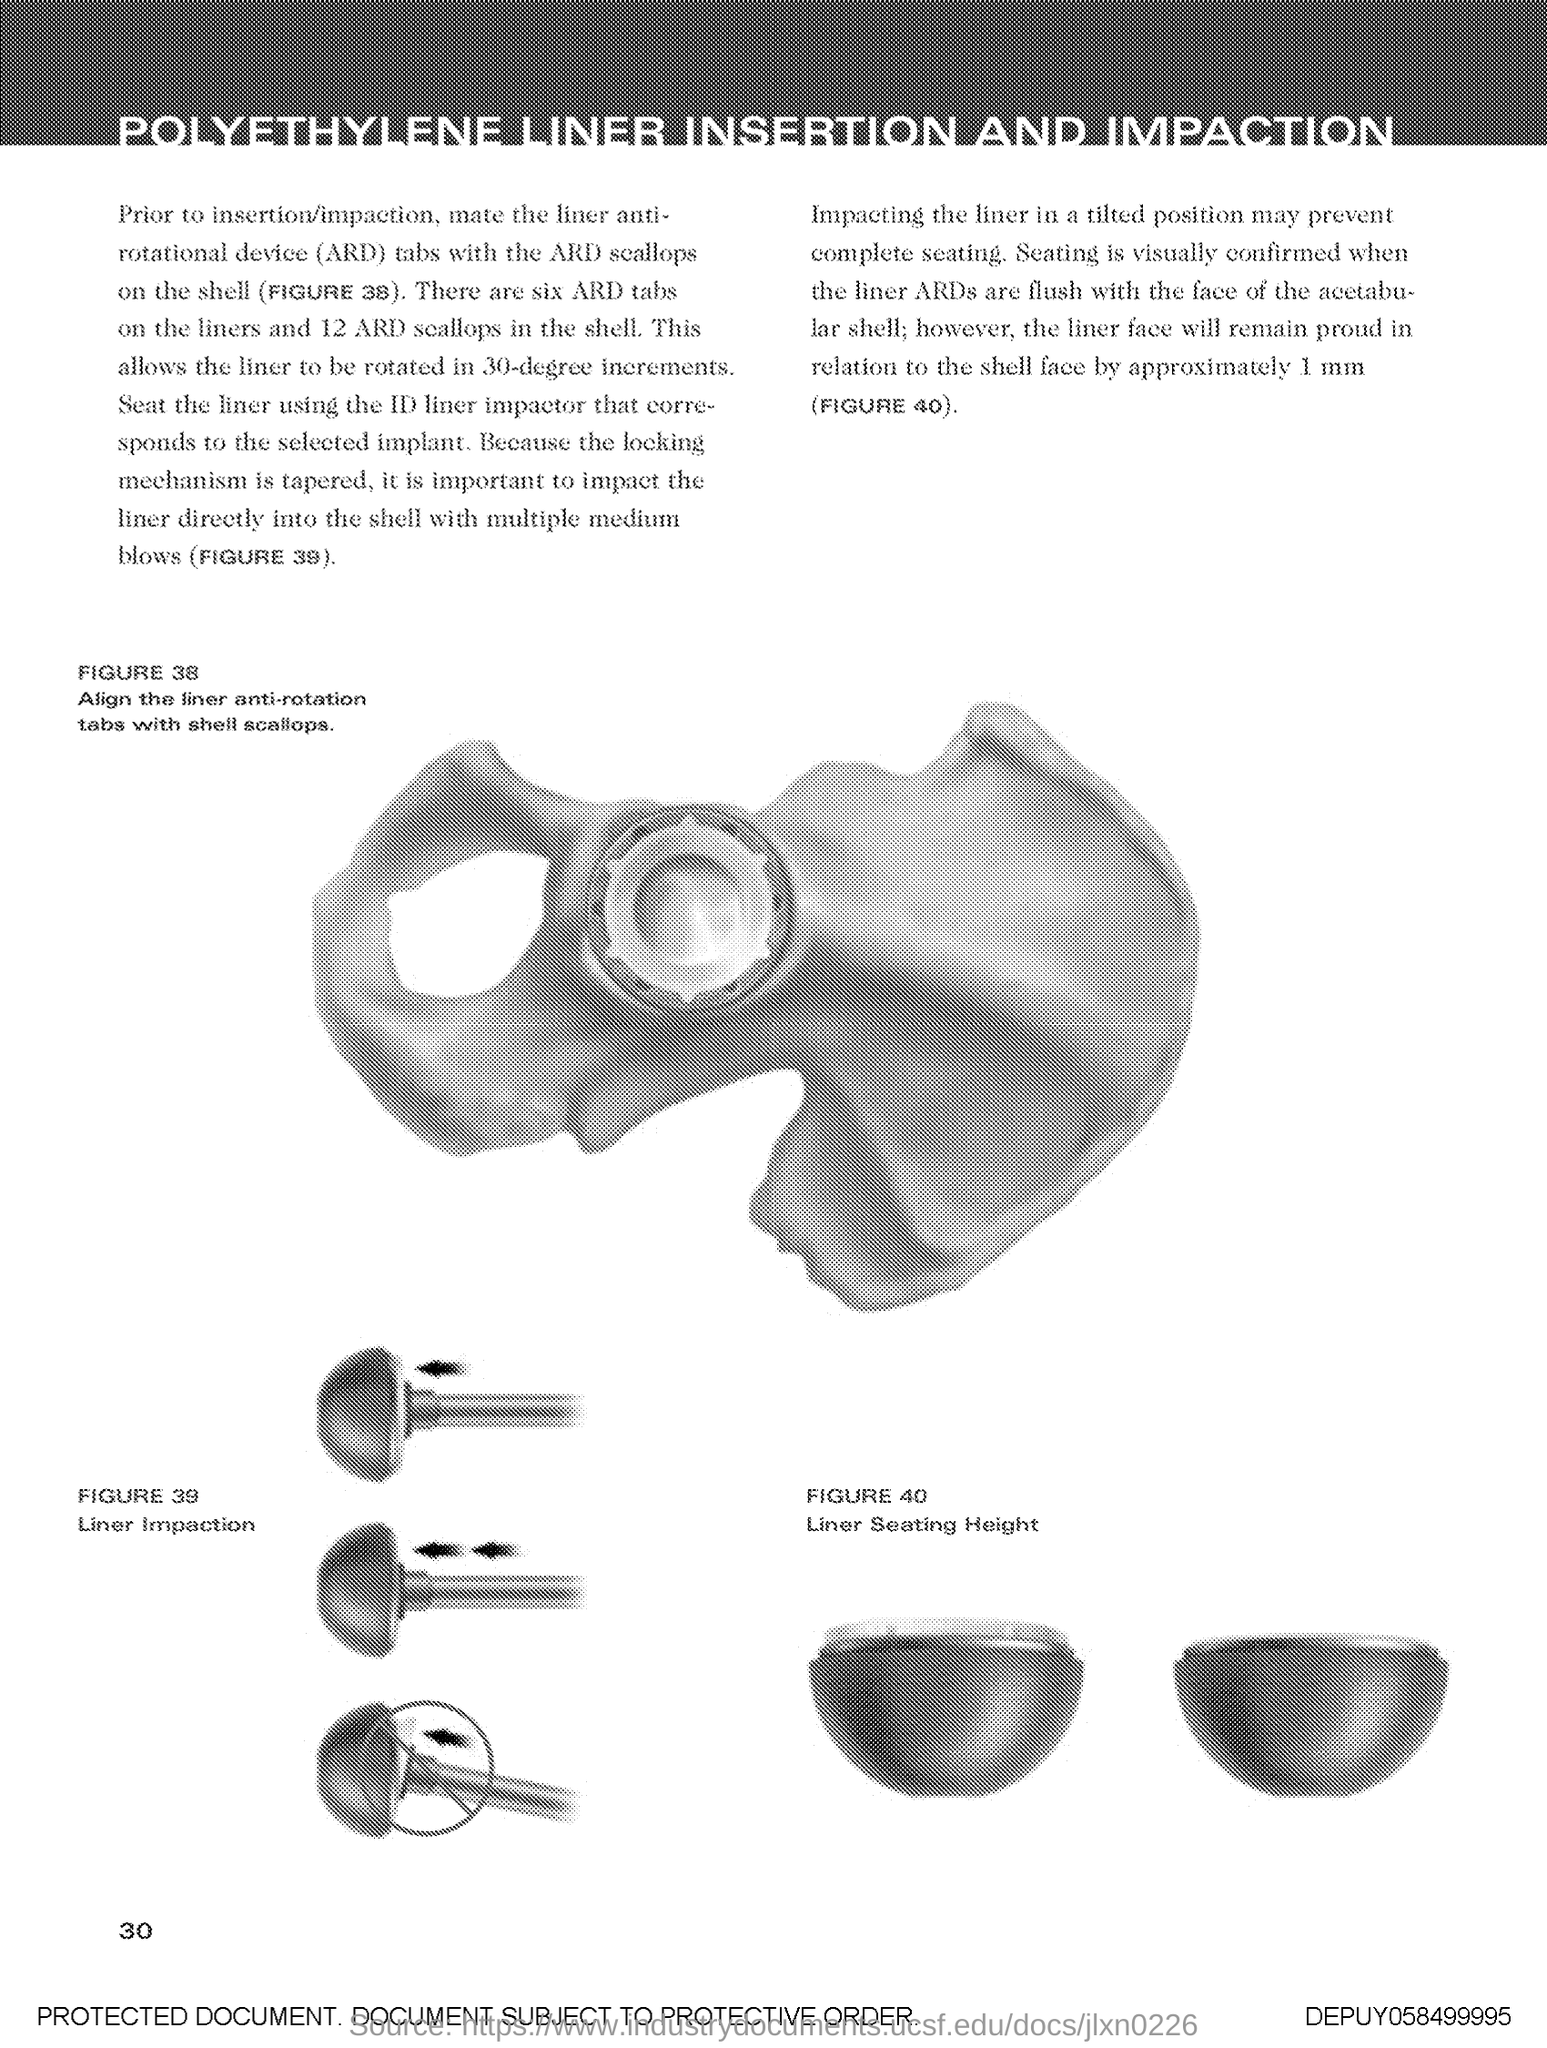What is the title of the document?
Provide a short and direct response. Polyethylene Liner Insertion and Impaction. What is the Page Number?
Make the answer very short. 30. 